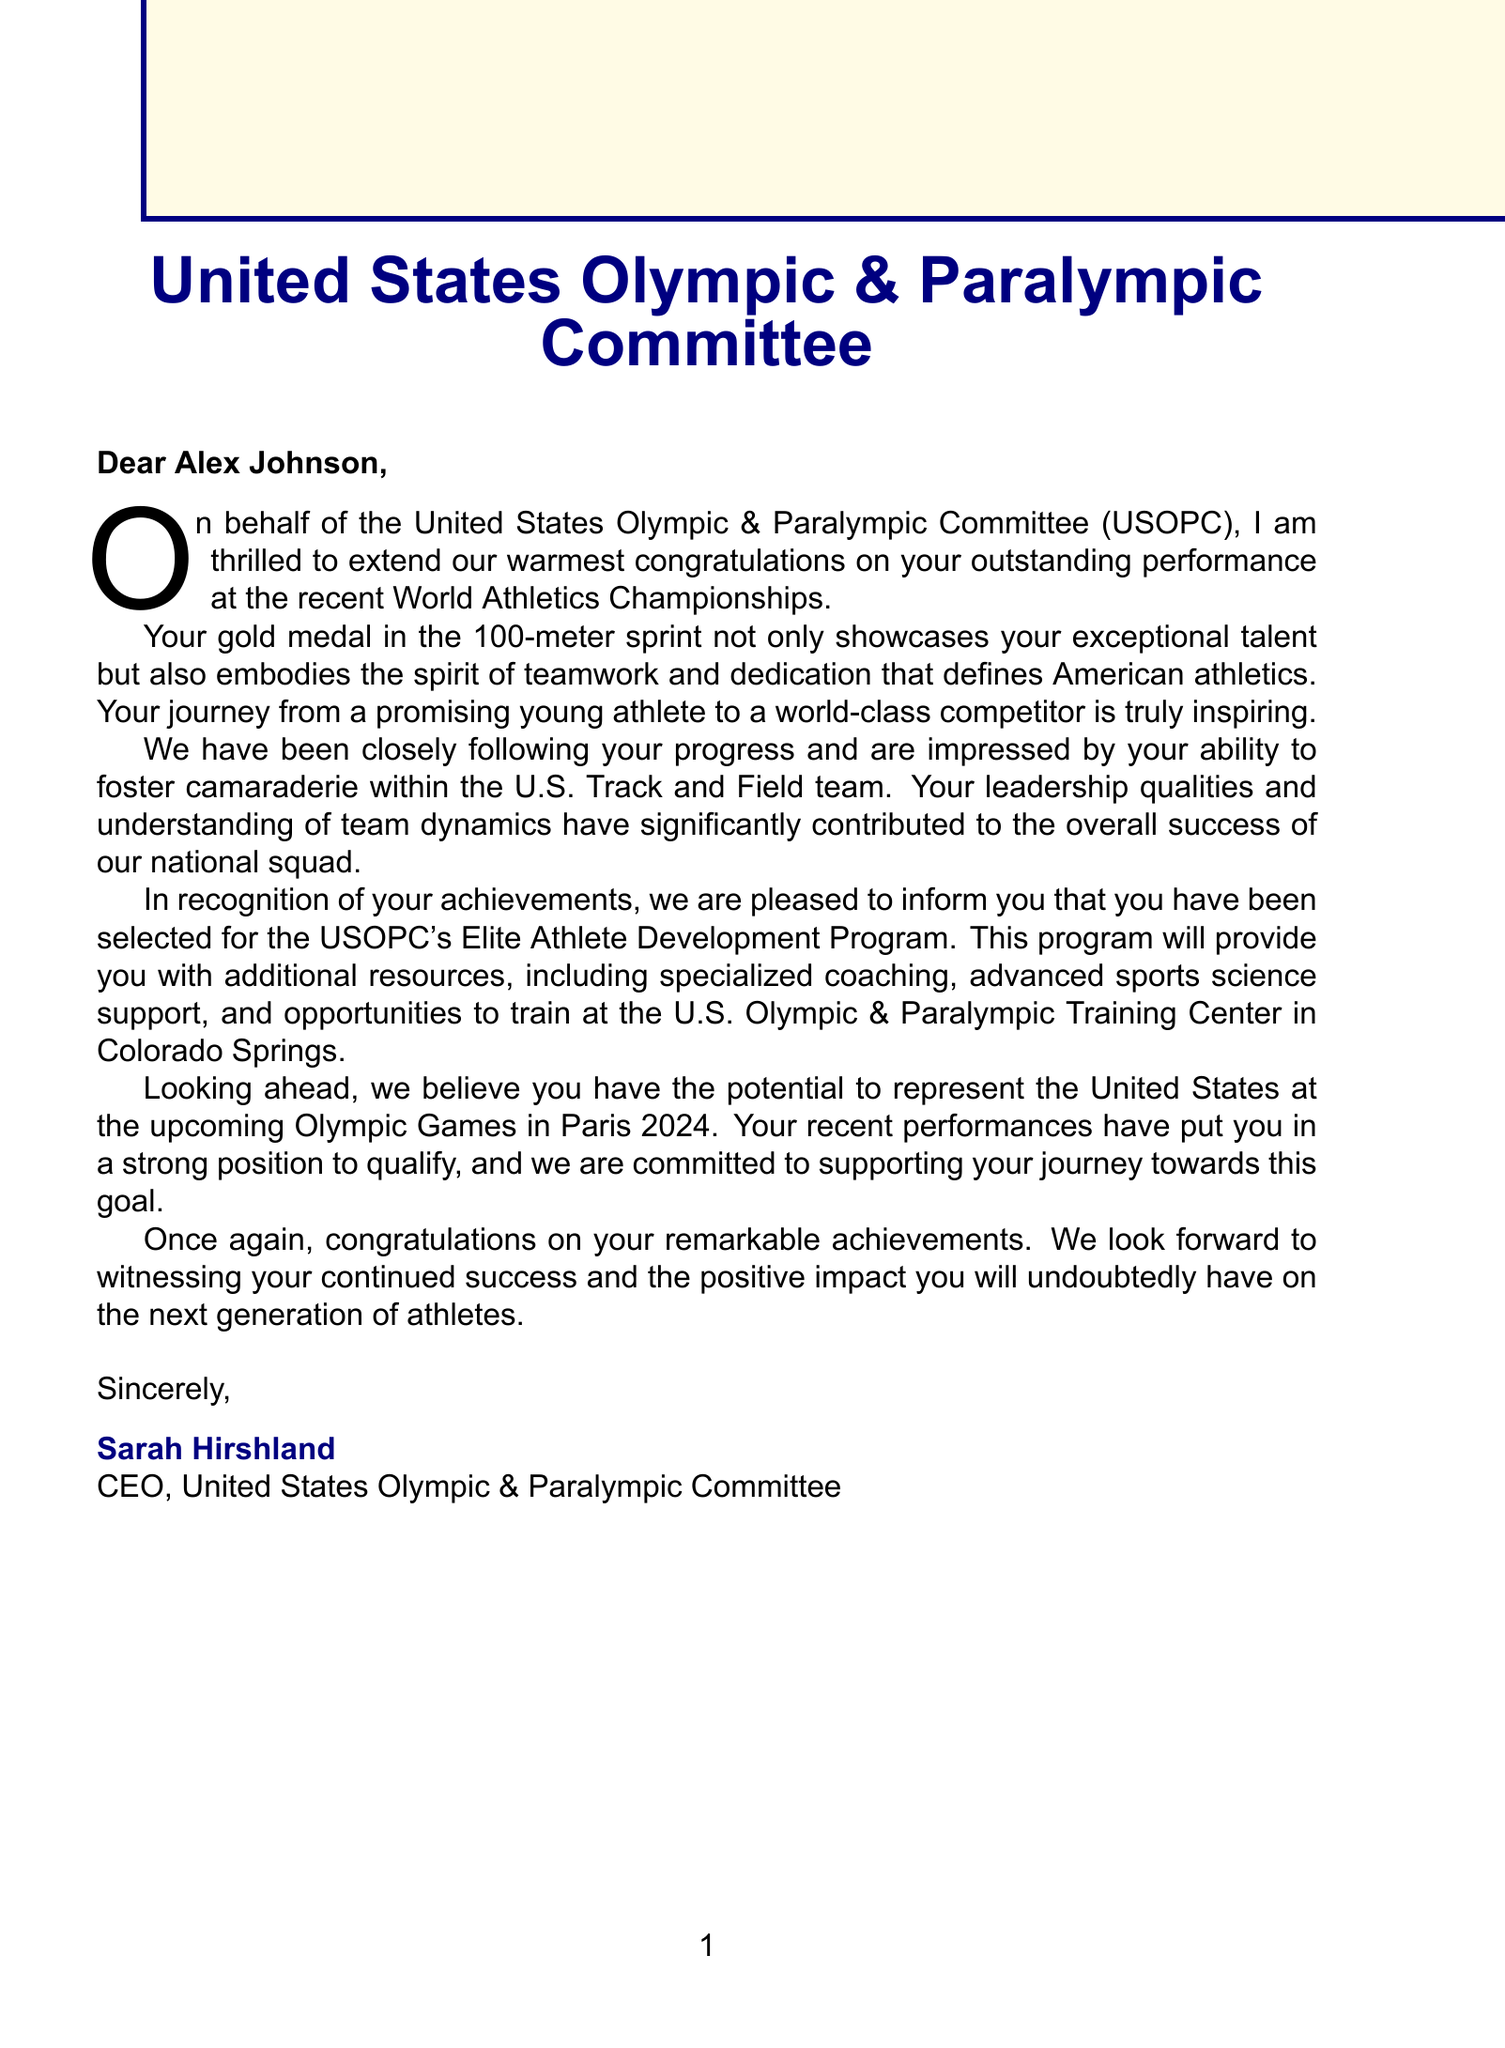What is the athlete's name? The athlete's name mentioned in the letter is Alex Johnson.
Answer: Alex Johnson What is the sport specialization of the athlete? The letter states that the athlete specializes in the 100-meter sprint.
Answer: 100-meter sprint What is the recent achievement recognized in the letter? The letter congratulates the athlete on winning a gold medal at the World Athletics Championships.
Answer: Gold medal at the World Athletics Championships What program has the athlete been selected for? The athlete has been selected for the USOPC's Elite Athlete Development Program.
Answer: Elite Athlete Development Program What city is the U.S. Olympic & Paralympic Training Center located in? The letter mentions that the training center is located in Colorado Springs.
Answer: Colorado Springs What is the upcoming major event the athlete is expected to participate in? The letter refers to the upcoming Olympic Games in Paris 2024 as a major international event.
Answer: Olympic Games Paris 2024 Who signed the letter? The CEO of the USOPC, Sarah Hirshland, is the one who signed the letter.
Answer: Sarah Hirshland What qualities of the athlete are praised in the letter? The letter praises the athlete's ability to foster camaraderie and contribute to team success.
Answer: Fostering camaraderie and contributing to team success What message does the letter convey regarding future impact? The letter expresses the belief that the athlete will inspire the next generation of athletes.
Answer: Inspiring the next generation of athletes 